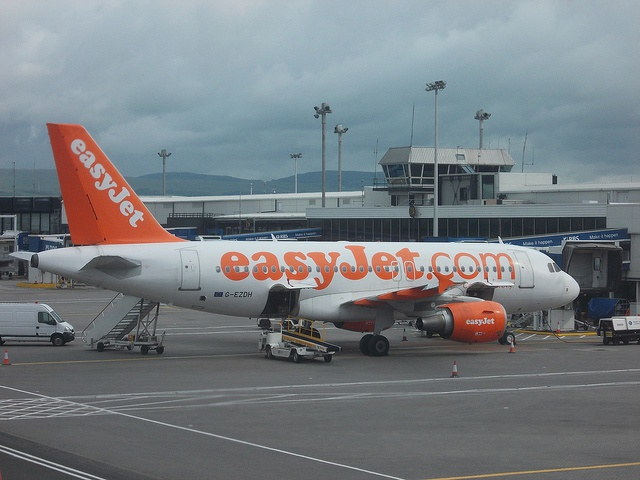Describe the objects in this image and their specific colors. I can see airplane in lightgray, darkgray, gray, and black tones, truck in lightgray, gray, and black tones, truck in lightgray, gray, black, darkgray, and olive tones, and truck in lightgray, black, darkgray, and gray tones in this image. 